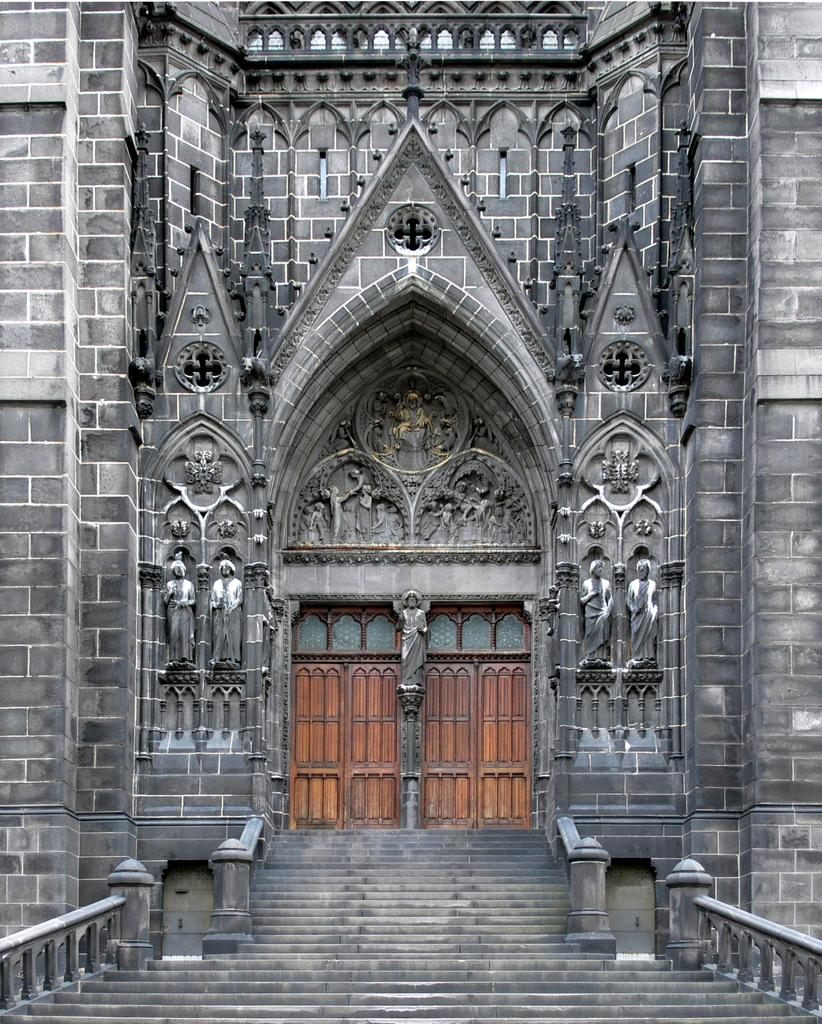What type of structure is present in the image? There is a building in the image. Can you describe the color of the building? The building is in gray color. What type of door is featured on the building? There is a wooden door in the image. What is the color of the wooden door? The wooden door is in brown color. How many friends are visible in the image? There are no friends present in the image. What type of ticket is required to enter the building in the image? There is no mention of a ticket or any requirement to enter the building in the image. 